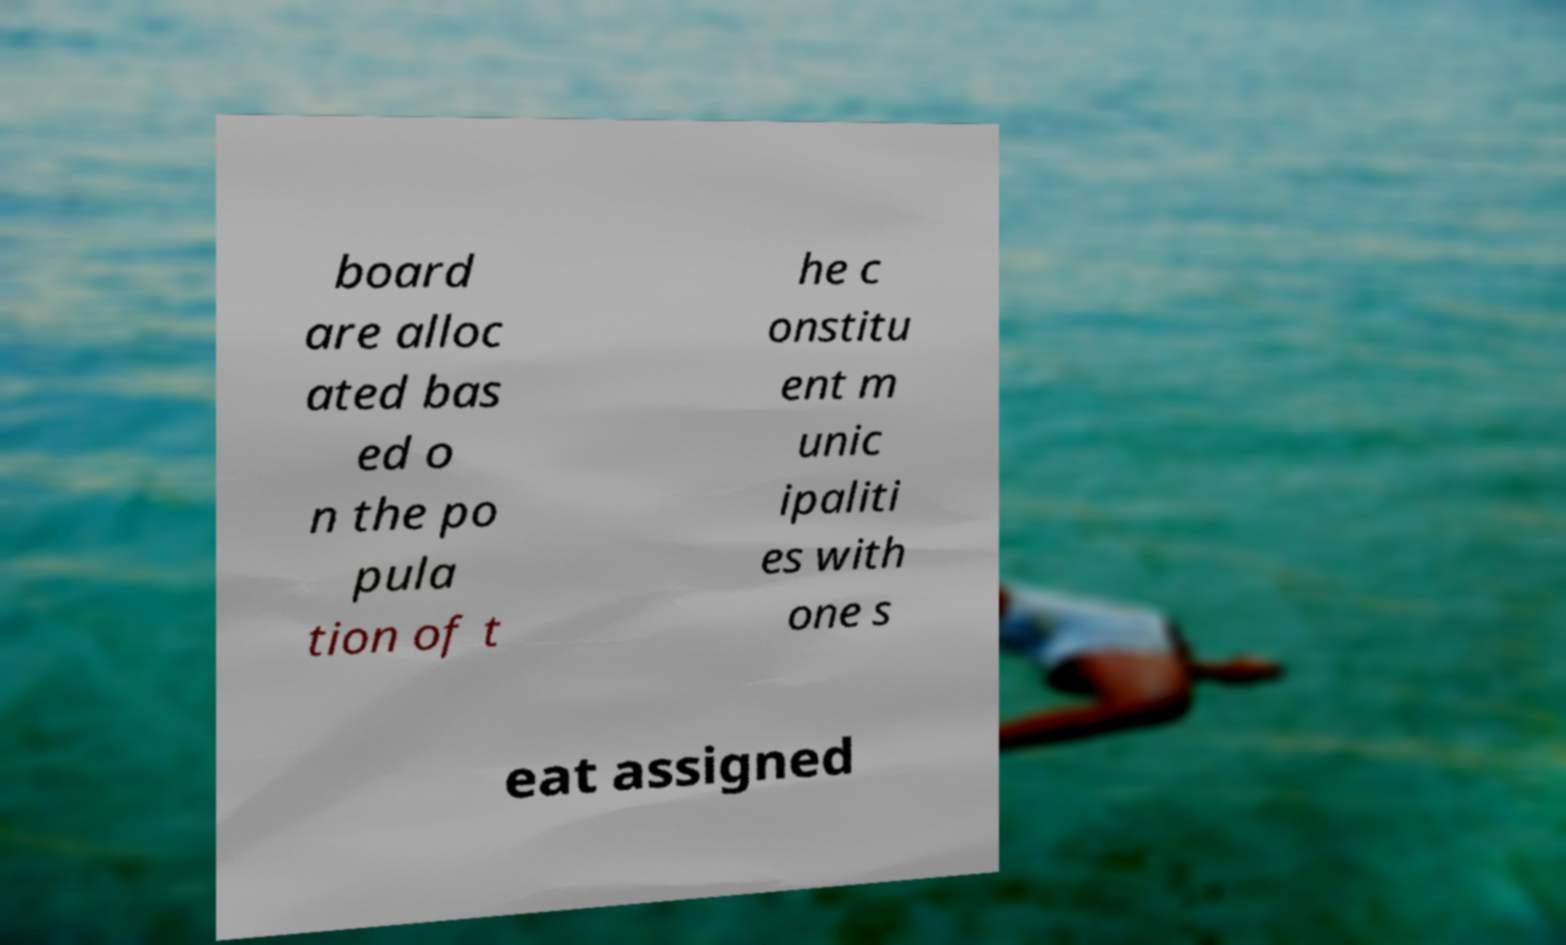I need the written content from this picture converted into text. Can you do that? board are alloc ated bas ed o n the po pula tion of t he c onstitu ent m unic ipaliti es with one s eat assigned 